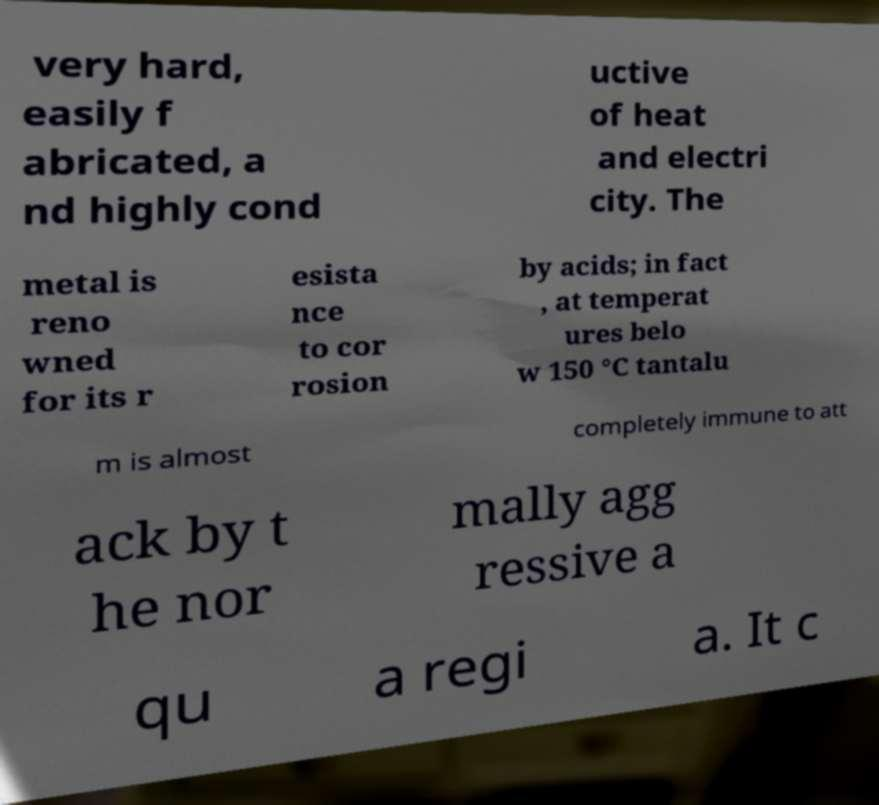Please identify and transcribe the text found in this image. very hard, easily f abricated, a nd highly cond uctive of heat and electri city. The metal is reno wned for its r esista nce to cor rosion by acids; in fact , at temperat ures belo w 150 °C tantalu m is almost completely immune to att ack by t he nor mally agg ressive a qu a regi a. It c 